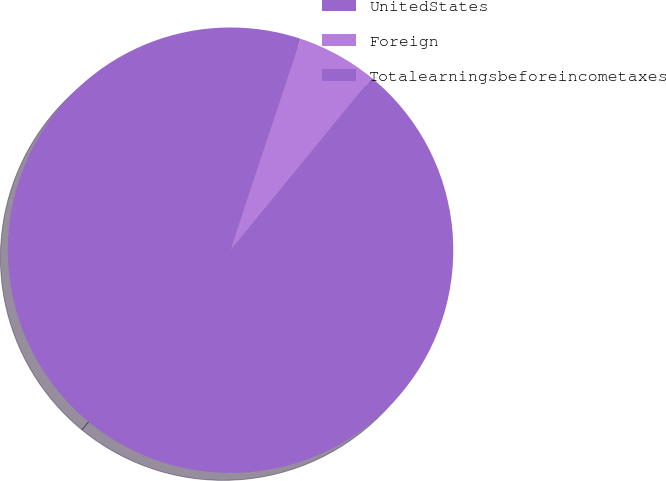<chart> <loc_0><loc_0><loc_500><loc_500><pie_chart><fcel>UnitedStates<fcel>Foreign<fcel>Totalearningsbeforeincometaxes<nl><fcel>44.17%<fcel>5.83%<fcel>50.0%<nl></chart> 